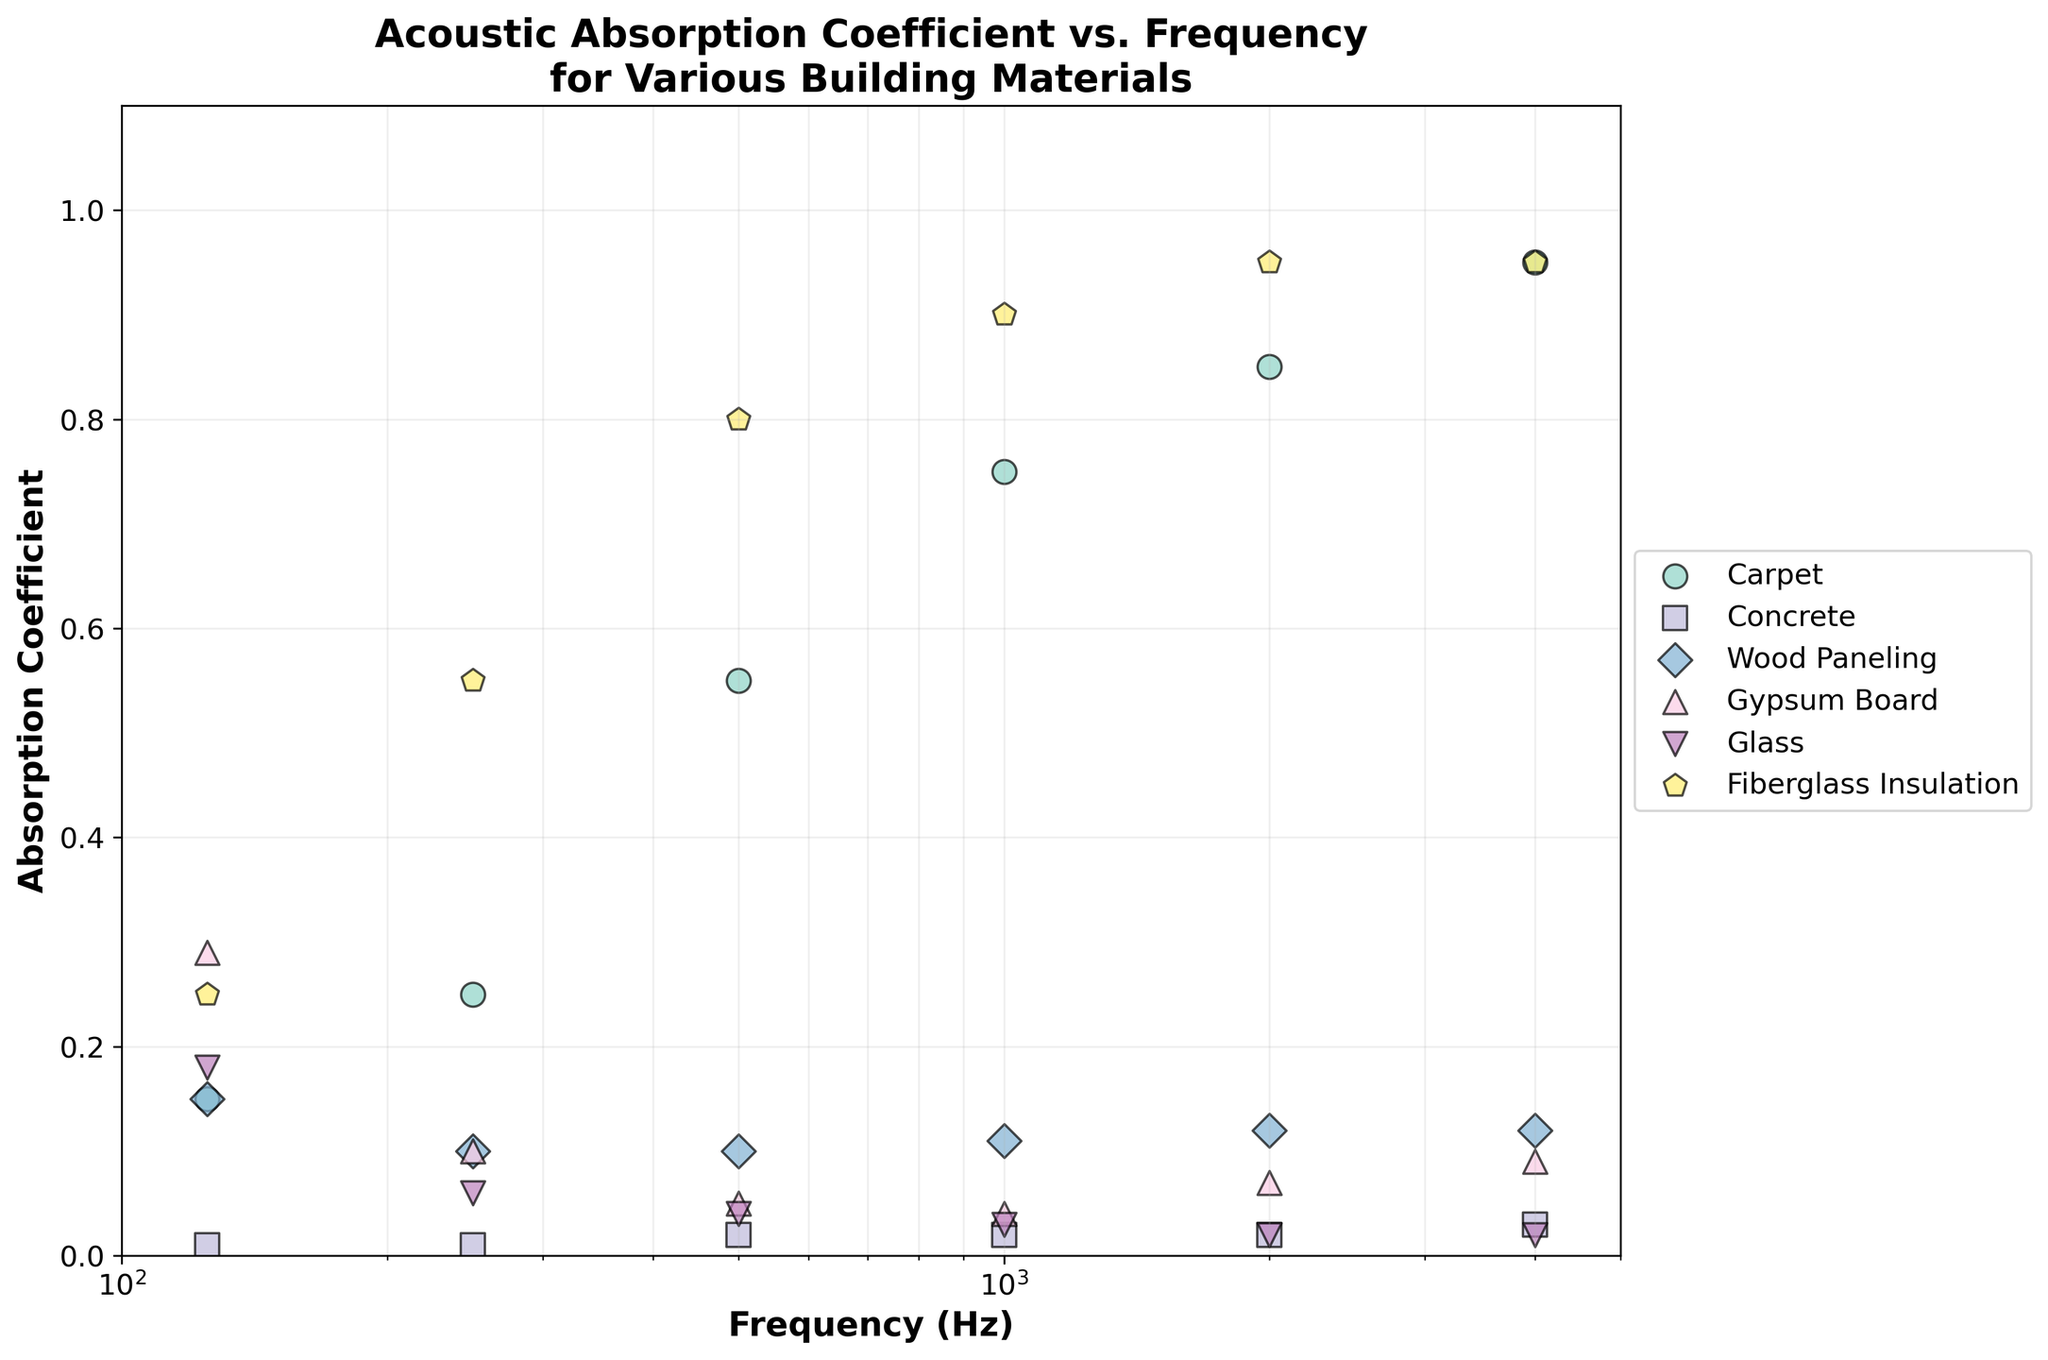What's the title of the plot? The title of the plot is clearly stated at the top of the figure.
Answer: Acoustic Absorption Coefficient vs. Frequency for Various Building Materials What are the x-axis and y-axis labels? The x-axis label reads "Frequency (Hz)" and the y-axis label reads "Absorption Coefficient." Both are indicated by the text directly on the axes.
Answer: Frequency (Hz) and Absorption Coefficient How many different materials are compared in the plot? The legend lists all the materials being compared, and by counting the unique entries in the legend, we find there are six different materials.
Answer: Six Which material has the highest absorption coefficient at 4000 Hz? By checking the highest y-value at 4000 Hz in the scatter points and referring to the legend for the corresponding color and marker, we see that both Fiberglass Insulation and Carpet have the highest absorption coefficient.
Answer: Fiberglass Insulation and Carpet What is the general trend of absorption coefficient for Fiberglass Insulation with increasing frequency? Observing the Fiberglass Insulation data points from low to high frequencies, we notice that the absorption coefficient consistently increases.
Answer: Increasing Which two materials have the lowest absorption coefficients across all frequencies? By examining the scatter points for the different materials, we see that Concrete and Glass consistently have the lowest absorption coefficients.
Answer: Concrete and Glass Compare the absorption coefficients of Carpet and Wood Paneling at 125 Hz. Which is higher? By looking at the scatter points for 125 Hz, we find Carpet is higher than Wood Paneling in terms of absorption coefficient.
Answer: Carpet What is the difference in absorption coefficient between Carpet and Gypsum Board at 2000 Hz? We find the absorption coefficient for Carpet at 2000 Hz (0.85) and for Gypsum Board at 2000 Hz (0.07). Subtracting these values gives the difference.
Answer: 0.78 Which material shows the least variation in absorption coefficient across all frequencies? By inspecting the consistency of the scatter points along the y-axis, Concrete has nearly the same absorption coefficient for all frequencies.
Answer: Concrete Is there any material that shows a significant increase in absorption coefficient between 125 Hz and 250 Hz? By comparing the values, we see that Fiberglass Insulation shows a significant increase in absorption coefficient from 0.25 at 125 Hz to 0.55 at 250 Hz.
Answer: Fiberglass Insulation 